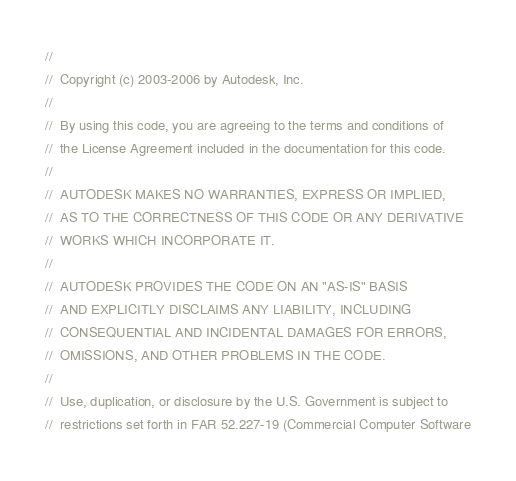<code> <loc_0><loc_0><loc_500><loc_500><_C_>//
//  Copyright (c) 2003-2006 by Autodesk, Inc.
//
//  By using this code, you are agreeing to the terms and conditions of
//  the License Agreement included in the documentation for this code.
//
//  AUTODESK MAKES NO WARRANTIES, EXPRESS OR IMPLIED,
//  AS TO THE CORRECTNESS OF THIS CODE OR ANY DERIVATIVE
//  WORKS WHICH INCORPORATE IT.
//
//  AUTODESK PROVIDES THE CODE ON AN "AS-IS" BASIS
//  AND EXPLICITLY DISCLAIMS ANY LIABILITY, INCLUDING
//  CONSEQUENTIAL AND INCIDENTAL DAMAGES FOR ERRORS,
//  OMISSIONS, AND OTHER PROBLEMS IN THE CODE.
//
//  Use, duplication, or disclosure by the U.S. Government is subject to
//  restrictions set forth in FAR 52.227-19 (Commercial Computer Software</code> 